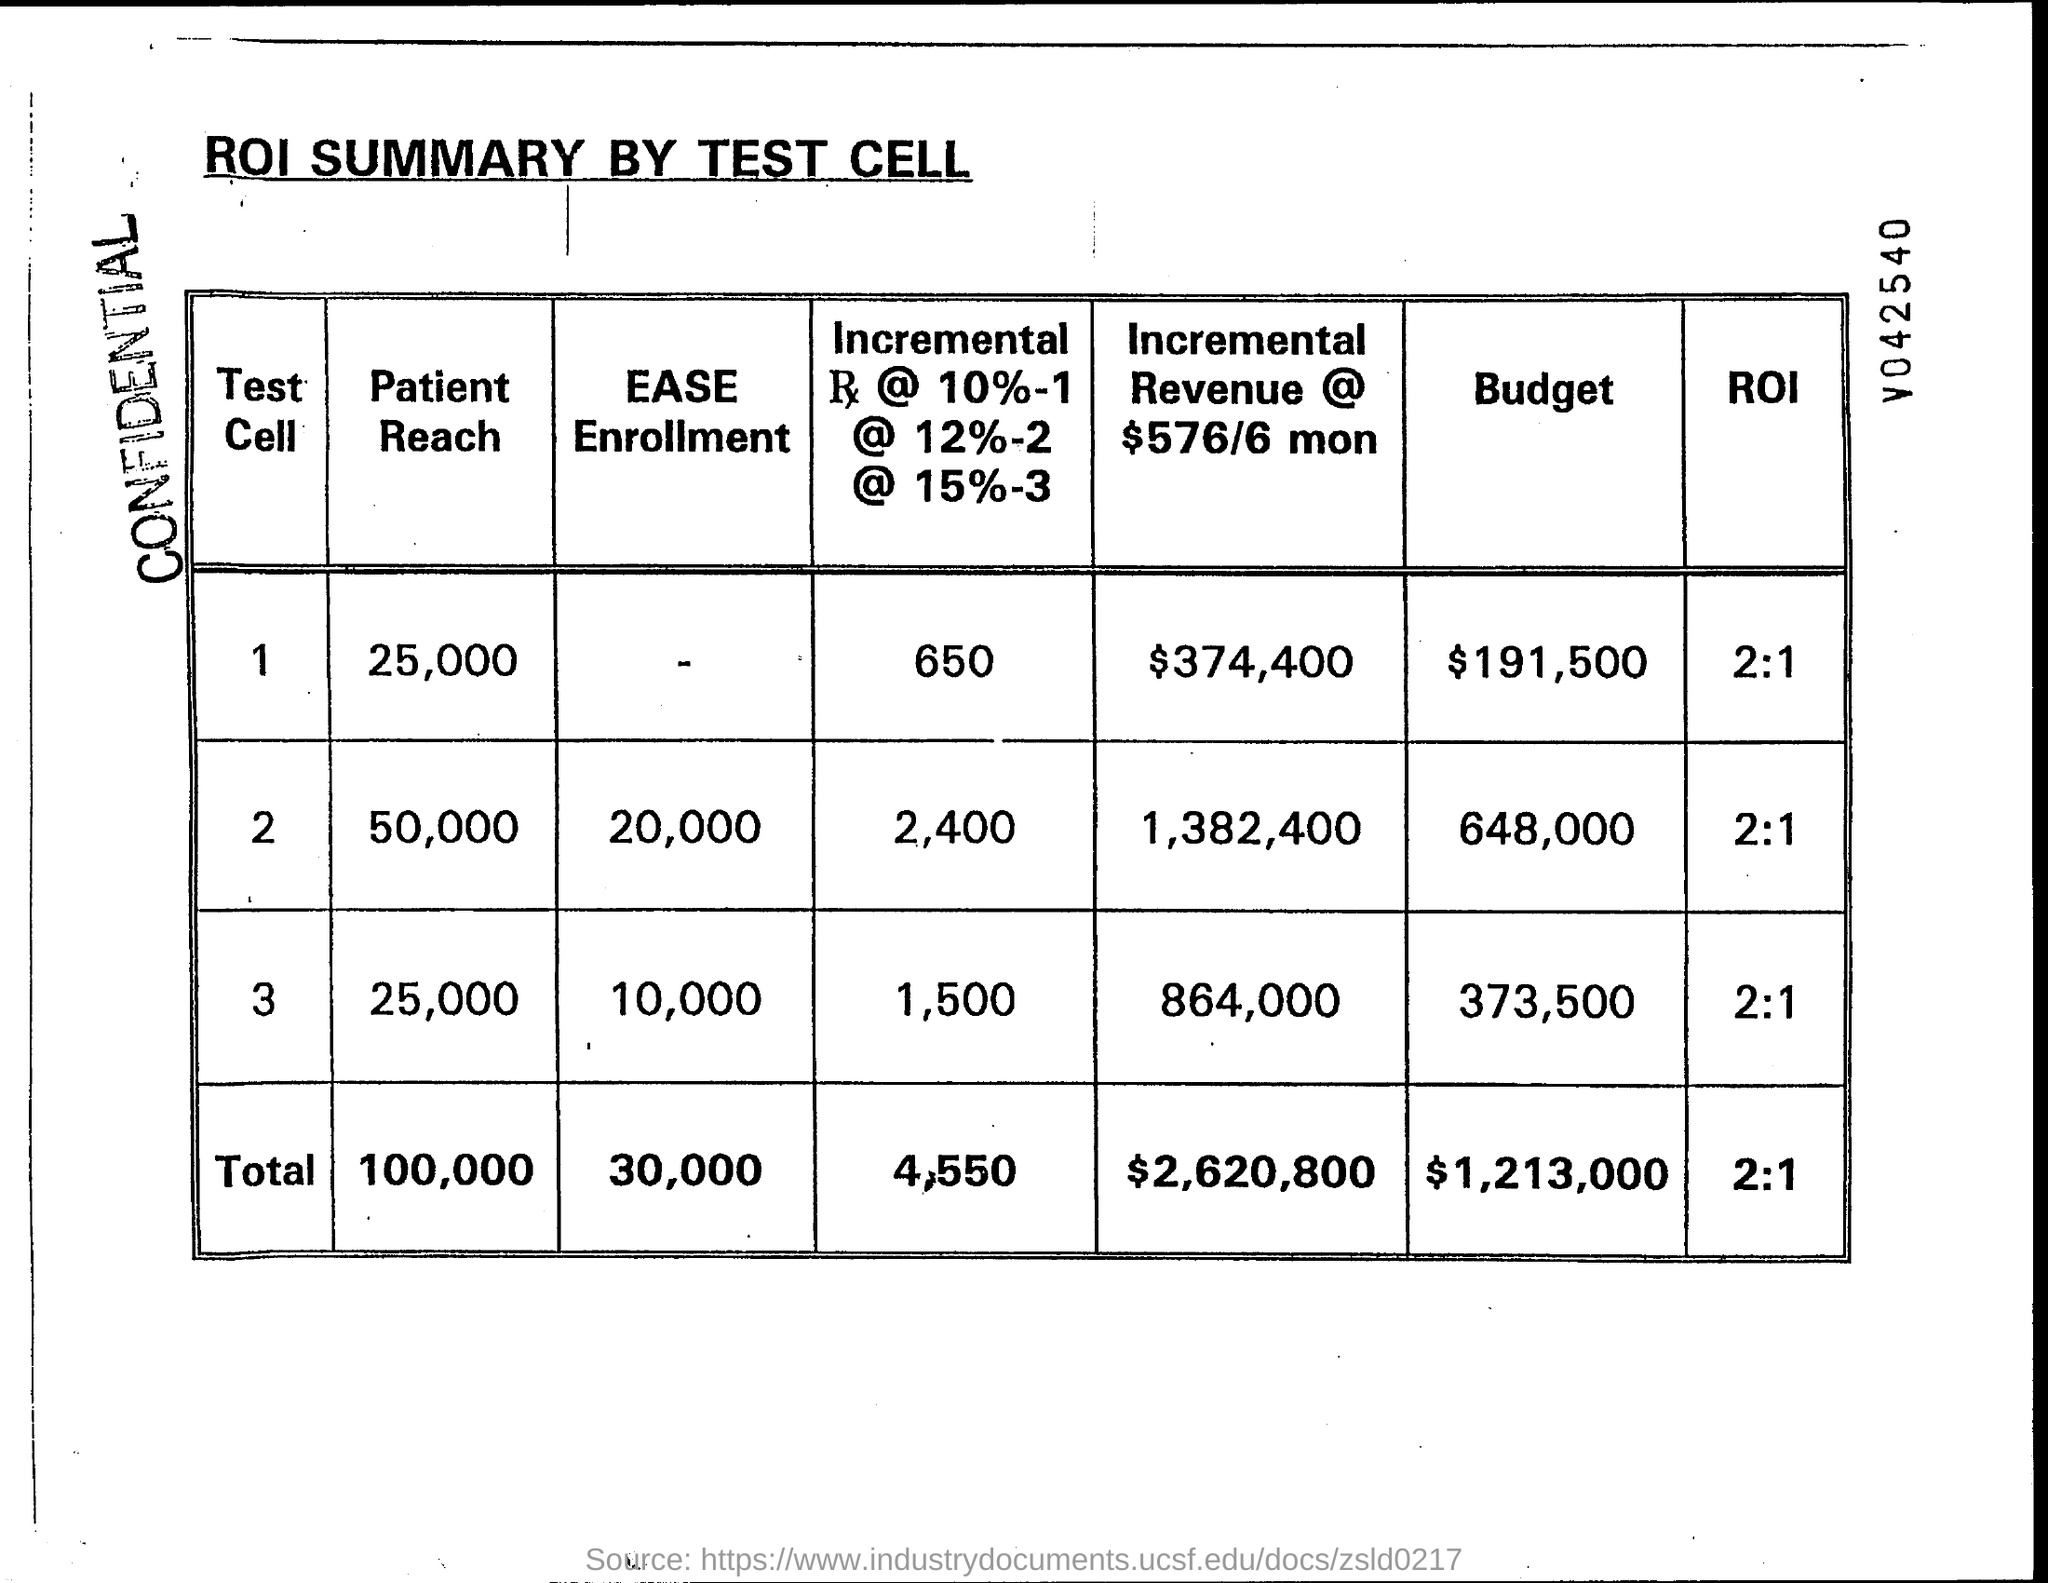Outline some significant characteristics in this image. The total budget is $1,213,000. As of November 2022, the total number of patients reached through this program is 100,000. The total enrollment is estimated to be 30,000. The total incremental revenue for 6 months, at a rate of $576 per minute, is $2,620,800. The total return on investment is 2:1, which indicates a positive outcome and a significant profit. 